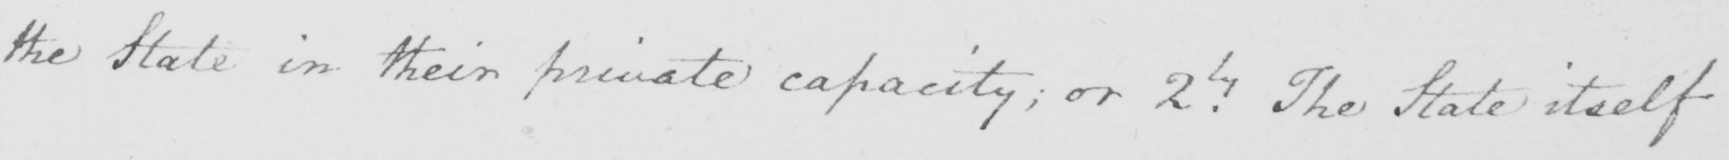Can you read and transcribe this handwriting? the State in their private capacity  ; or 2.ly The State itself 